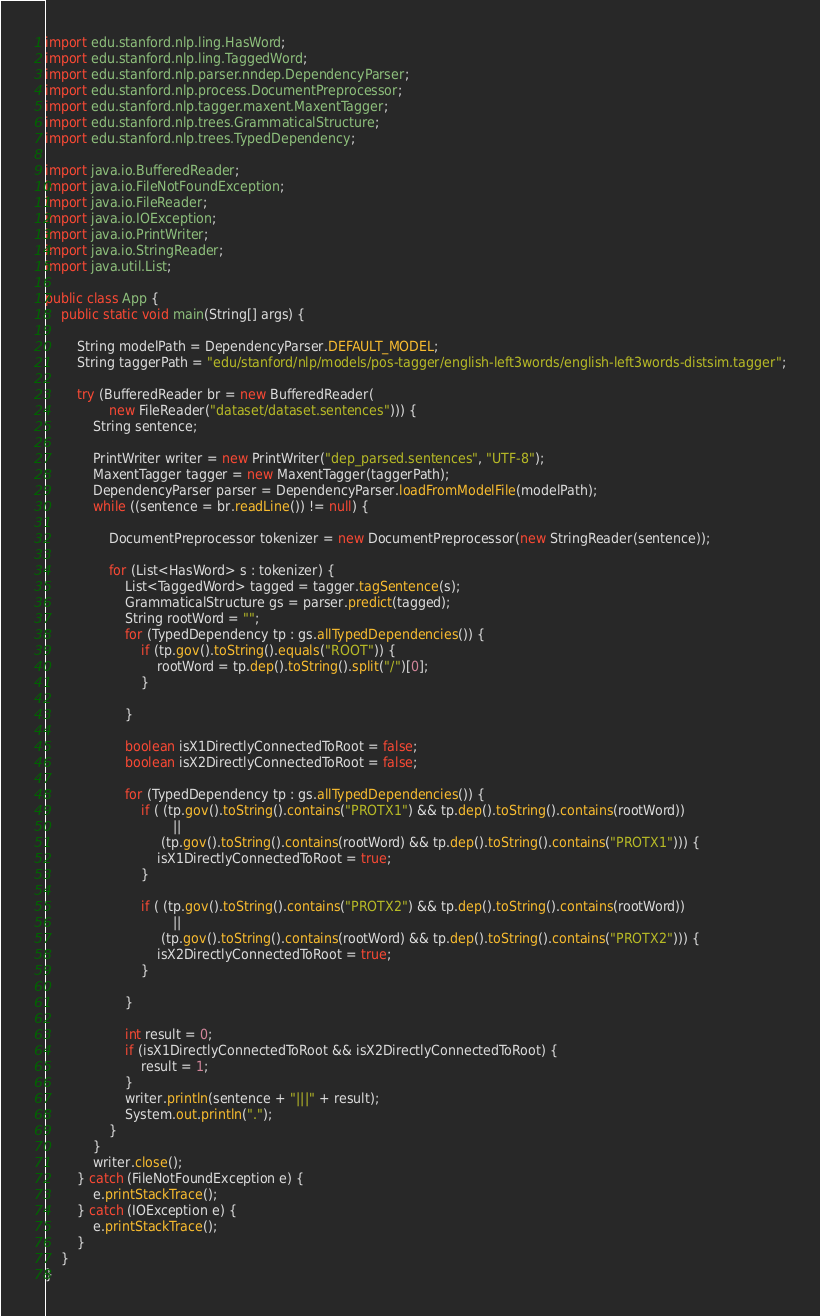<code> <loc_0><loc_0><loc_500><loc_500><_Java_>import edu.stanford.nlp.ling.HasWord;
import edu.stanford.nlp.ling.TaggedWord;
import edu.stanford.nlp.parser.nndep.DependencyParser;
import edu.stanford.nlp.process.DocumentPreprocessor;
import edu.stanford.nlp.tagger.maxent.MaxentTagger;
import edu.stanford.nlp.trees.GrammaticalStructure;
import edu.stanford.nlp.trees.TypedDependency;

import java.io.BufferedReader;
import java.io.FileNotFoundException;
import java.io.FileReader;
import java.io.IOException;
import java.io.PrintWriter;
import java.io.StringReader;
import java.util.List;

public class App {
	public static void main(String[] args) {

		String modelPath = DependencyParser.DEFAULT_MODEL;
		String taggerPath = "edu/stanford/nlp/models/pos-tagger/english-left3words/english-left3words-distsim.tagger";

		try (BufferedReader br = new BufferedReader(
				new FileReader("dataset/dataset.sentences"))) {
			String sentence;
			
			PrintWriter writer = new PrintWriter("dep_parsed.sentences", "UTF-8");
			MaxentTagger tagger = new MaxentTagger(taggerPath);
			DependencyParser parser = DependencyParser.loadFromModelFile(modelPath);
			while ((sentence = br.readLine()) != null) {

				DocumentPreprocessor tokenizer = new DocumentPreprocessor(new StringReader(sentence));
				
				for (List<HasWord> s : tokenizer) {
					List<TaggedWord> tagged = tagger.tagSentence(s);
					GrammaticalStructure gs = parser.predict(tagged);
					String rootWord = "";
					for (TypedDependency tp : gs.allTypedDependencies()) {
						if (tp.gov().toString().equals("ROOT")) {
							rootWord = tp.dep().toString().split("/")[0];
						}
	
					}
					
					boolean isX1DirectlyConnectedToRoot = false;
					boolean isX2DirectlyConnectedToRoot = false;
					
					for (TypedDependency tp : gs.allTypedDependencies()) {
						if ( (tp.gov().toString().contains("PROTX1") && tp.dep().toString().contains(rootWord)) 
								||
							 (tp.gov().toString().contains(rootWord) && tp.dep().toString().contains("PROTX1"))) {
							isX1DirectlyConnectedToRoot = true;
						}
						
						if ( (tp.gov().toString().contains("PROTX2") && tp.dep().toString().contains(rootWord)) 
								||
							 (tp.gov().toString().contains(rootWord) && tp.dep().toString().contains("PROTX2"))) {
							isX2DirectlyConnectedToRoot = true;
						}
						
					}

					int result = 0;
					if (isX1DirectlyConnectedToRoot && isX2DirectlyConnectedToRoot) {
						result = 1;
					}
					writer.println(sentence + "|||" + result);
					System.out.println(".");
				}
			}
			writer.close();
		} catch (FileNotFoundException e) {
			e.printStackTrace();
		} catch (IOException e) {
			e.printStackTrace();
		}
	}
}

</code> 